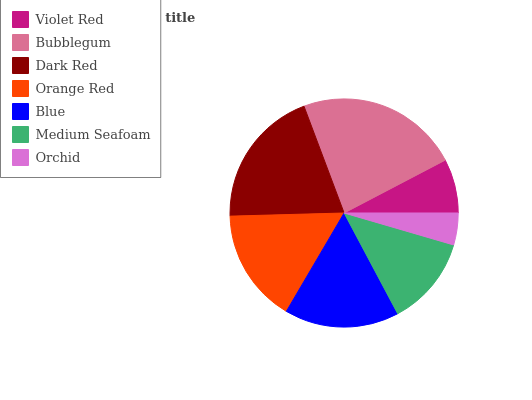Is Orchid the minimum?
Answer yes or no. Yes. Is Bubblegum the maximum?
Answer yes or no. Yes. Is Dark Red the minimum?
Answer yes or no. No. Is Dark Red the maximum?
Answer yes or no. No. Is Bubblegum greater than Dark Red?
Answer yes or no. Yes. Is Dark Red less than Bubblegum?
Answer yes or no. Yes. Is Dark Red greater than Bubblegum?
Answer yes or no. No. Is Bubblegum less than Dark Red?
Answer yes or no. No. Is Orange Red the high median?
Answer yes or no. Yes. Is Orange Red the low median?
Answer yes or no. Yes. Is Dark Red the high median?
Answer yes or no. No. Is Medium Seafoam the low median?
Answer yes or no. No. 